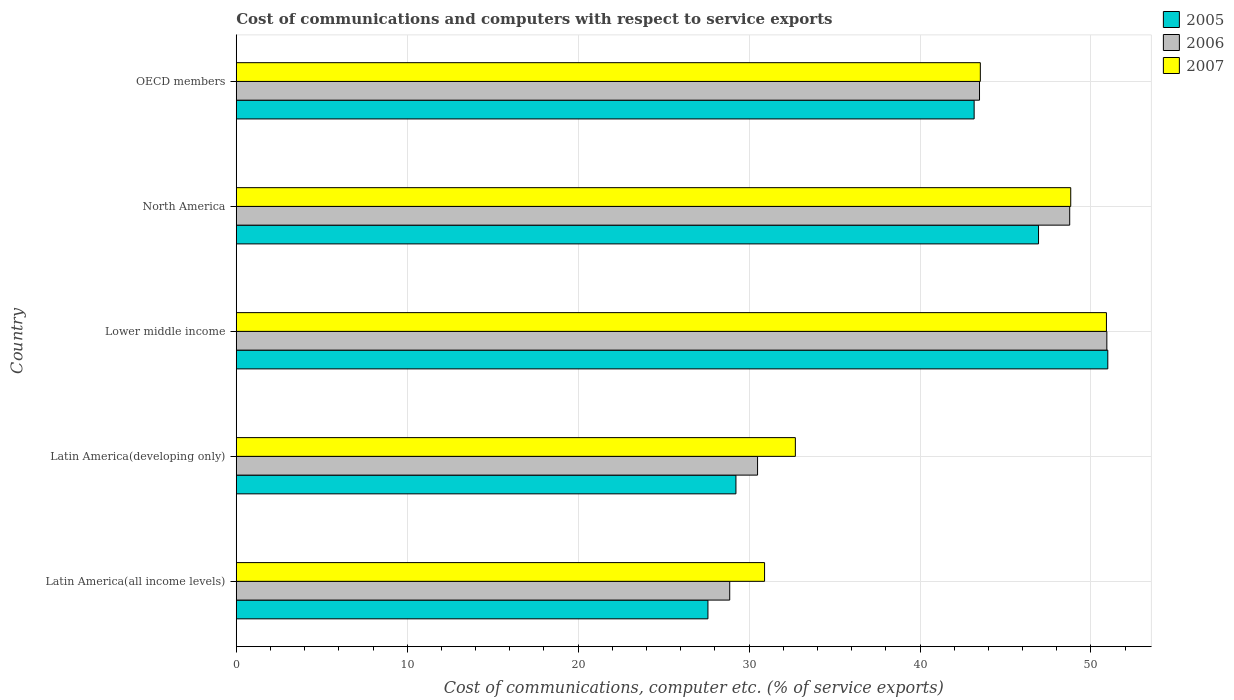How many different coloured bars are there?
Keep it short and to the point. 3. How many groups of bars are there?
Provide a short and direct response. 5. Are the number of bars per tick equal to the number of legend labels?
Your answer should be very brief. Yes. Are the number of bars on each tick of the Y-axis equal?
Offer a terse response. Yes. In how many cases, is the number of bars for a given country not equal to the number of legend labels?
Provide a short and direct response. 0. What is the cost of communications and computers in 2006 in North America?
Offer a terse response. 48.76. Across all countries, what is the maximum cost of communications and computers in 2005?
Provide a succinct answer. 50.99. Across all countries, what is the minimum cost of communications and computers in 2005?
Your response must be concise. 27.59. In which country was the cost of communications and computers in 2006 maximum?
Give a very brief answer. Lower middle income. In which country was the cost of communications and computers in 2006 minimum?
Your response must be concise. Latin America(all income levels). What is the total cost of communications and computers in 2007 in the graph?
Make the answer very short. 206.87. What is the difference between the cost of communications and computers in 2005 in Latin America(all income levels) and that in Lower middle income?
Keep it short and to the point. -23.39. What is the difference between the cost of communications and computers in 2005 in Latin America(all income levels) and the cost of communications and computers in 2007 in OECD members?
Provide a short and direct response. -15.94. What is the average cost of communications and computers in 2007 per country?
Make the answer very short. 41.37. What is the difference between the cost of communications and computers in 2005 and cost of communications and computers in 2006 in Lower middle income?
Offer a terse response. 0.05. In how many countries, is the cost of communications and computers in 2006 greater than 20 %?
Offer a terse response. 5. What is the ratio of the cost of communications and computers in 2006 in Lower middle income to that in North America?
Make the answer very short. 1.04. Is the cost of communications and computers in 2005 in Latin America(all income levels) less than that in Lower middle income?
Provide a short and direct response. Yes. Is the difference between the cost of communications and computers in 2005 in Lower middle income and OECD members greater than the difference between the cost of communications and computers in 2006 in Lower middle income and OECD members?
Make the answer very short. Yes. What is the difference between the highest and the second highest cost of communications and computers in 2005?
Make the answer very short. 4.05. What is the difference between the highest and the lowest cost of communications and computers in 2005?
Offer a terse response. 23.39. In how many countries, is the cost of communications and computers in 2007 greater than the average cost of communications and computers in 2007 taken over all countries?
Your answer should be very brief. 3. What does the 1st bar from the top in OECD members represents?
Provide a short and direct response. 2007. What does the 1st bar from the bottom in North America represents?
Provide a short and direct response. 2005. Are all the bars in the graph horizontal?
Your response must be concise. Yes. How many countries are there in the graph?
Keep it short and to the point. 5. Does the graph contain any zero values?
Your answer should be compact. No. Does the graph contain grids?
Provide a short and direct response. Yes. How are the legend labels stacked?
Give a very brief answer. Vertical. What is the title of the graph?
Offer a terse response. Cost of communications and computers with respect to service exports. What is the label or title of the X-axis?
Offer a terse response. Cost of communications, computer etc. (% of service exports). What is the Cost of communications, computer etc. (% of service exports) in 2005 in Latin America(all income levels)?
Give a very brief answer. 27.59. What is the Cost of communications, computer etc. (% of service exports) in 2006 in Latin America(all income levels)?
Your answer should be very brief. 28.87. What is the Cost of communications, computer etc. (% of service exports) in 2007 in Latin America(all income levels)?
Make the answer very short. 30.91. What is the Cost of communications, computer etc. (% of service exports) of 2005 in Latin America(developing only)?
Your response must be concise. 29.23. What is the Cost of communications, computer etc. (% of service exports) of 2006 in Latin America(developing only)?
Keep it short and to the point. 30.5. What is the Cost of communications, computer etc. (% of service exports) of 2007 in Latin America(developing only)?
Ensure brevity in your answer.  32.71. What is the Cost of communications, computer etc. (% of service exports) in 2005 in Lower middle income?
Keep it short and to the point. 50.99. What is the Cost of communications, computer etc. (% of service exports) of 2006 in Lower middle income?
Provide a short and direct response. 50.93. What is the Cost of communications, computer etc. (% of service exports) in 2007 in Lower middle income?
Your answer should be compact. 50.91. What is the Cost of communications, computer etc. (% of service exports) in 2005 in North America?
Make the answer very short. 46.93. What is the Cost of communications, computer etc. (% of service exports) in 2006 in North America?
Your response must be concise. 48.76. What is the Cost of communications, computer etc. (% of service exports) of 2007 in North America?
Your response must be concise. 48.82. What is the Cost of communications, computer etc. (% of service exports) of 2005 in OECD members?
Your answer should be very brief. 43.17. What is the Cost of communications, computer etc. (% of service exports) of 2006 in OECD members?
Provide a short and direct response. 43.48. What is the Cost of communications, computer etc. (% of service exports) of 2007 in OECD members?
Ensure brevity in your answer.  43.53. Across all countries, what is the maximum Cost of communications, computer etc. (% of service exports) in 2005?
Your answer should be very brief. 50.99. Across all countries, what is the maximum Cost of communications, computer etc. (% of service exports) of 2006?
Make the answer very short. 50.93. Across all countries, what is the maximum Cost of communications, computer etc. (% of service exports) of 2007?
Your response must be concise. 50.91. Across all countries, what is the minimum Cost of communications, computer etc. (% of service exports) of 2005?
Ensure brevity in your answer.  27.59. Across all countries, what is the minimum Cost of communications, computer etc. (% of service exports) of 2006?
Offer a terse response. 28.87. Across all countries, what is the minimum Cost of communications, computer etc. (% of service exports) in 2007?
Your response must be concise. 30.91. What is the total Cost of communications, computer etc. (% of service exports) of 2005 in the graph?
Provide a short and direct response. 197.91. What is the total Cost of communications, computer etc. (% of service exports) in 2006 in the graph?
Provide a short and direct response. 202.54. What is the total Cost of communications, computer etc. (% of service exports) of 2007 in the graph?
Keep it short and to the point. 206.87. What is the difference between the Cost of communications, computer etc. (% of service exports) in 2005 in Latin America(all income levels) and that in Latin America(developing only)?
Give a very brief answer. -1.64. What is the difference between the Cost of communications, computer etc. (% of service exports) in 2006 in Latin America(all income levels) and that in Latin America(developing only)?
Your answer should be compact. -1.63. What is the difference between the Cost of communications, computer etc. (% of service exports) in 2007 in Latin America(all income levels) and that in Latin America(developing only)?
Keep it short and to the point. -1.8. What is the difference between the Cost of communications, computer etc. (% of service exports) in 2005 in Latin America(all income levels) and that in Lower middle income?
Provide a succinct answer. -23.39. What is the difference between the Cost of communications, computer etc. (% of service exports) in 2006 in Latin America(all income levels) and that in Lower middle income?
Offer a very short reply. -22.06. What is the difference between the Cost of communications, computer etc. (% of service exports) of 2007 in Latin America(all income levels) and that in Lower middle income?
Ensure brevity in your answer.  -20. What is the difference between the Cost of communications, computer etc. (% of service exports) in 2005 in Latin America(all income levels) and that in North America?
Provide a short and direct response. -19.34. What is the difference between the Cost of communications, computer etc. (% of service exports) of 2006 in Latin America(all income levels) and that in North America?
Your answer should be very brief. -19.89. What is the difference between the Cost of communications, computer etc. (% of service exports) in 2007 in Latin America(all income levels) and that in North America?
Your answer should be very brief. -17.91. What is the difference between the Cost of communications, computer etc. (% of service exports) of 2005 in Latin America(all income levels) and that in OECD members?
Ensure brevity in your answer.  -15.57. What is the difference between the Cost of communications, computer etc. (% of service exports) of 2006 in Latin America(all income levels) and that in OECD members?
Give a very brief answer. -14.61. What is the difference between the Cost of communications, computer etc. (% of service exports) in 2007 in Latin America(all income levels) and that in OECD members?
Provide a succinct answer. -12.62. What is the difference between the Cost of communications, computer etc. (% of service exports) in 2005 in Latin America(developing only) and that in Lower middle income?
Ensure brevity in your answer.  -21.75. What is the difference between the Cost of communications, computer etc. (% of service exports) in 2006 in Latin America(developing only) and that in Lower middle income?
Keep it short and to the point. -20.43. What is the difference between the Cost of communications, computer etc. (% of service exports) in 2007 in Latin America(developing only) and that in Lower middle income?
Offer a terse response. -18.2. What is the difference between the Cost of communications, computer etc. (% of service exports) of 2005 in Latin America(developing only) and that in North America?
Offer a terse response. -17.7. What is the difference between the Cost of communications, computer etc. (% of service exports) in 2006 in Latin America(developing only) and that in North America?
Your answer should be compact. -18.26. What is the difference between the Cost of communications, computer etc. (% of service exports) of 2007 in Latin America(developing only) and that in North America?
Your response must be concise. -16.11. What is the difference between the Cost of communications, computer etc. (% of service exports) in 2005 in Latin America(developing only) and that in OECD members?
Provide a short and direct response. -13.93. What is the difference between the Cost of communications, computer etc. (% of service exports) in 2006 in Latin America(developing only) and that in OECD members?
Keep it short and to the point. -12.98. What is the difference between the Cost of communications, computer etc. (% of service exports) in 2007 in Latin America(developing only) and that in OECD members?
Give a very brief answer. -10.82. What is the difference between the Cost of communications, computer etc. (% of service exports) of 2005 in Lower middle income and that in North America?
Offer a very short reply. 4.05. What is the difference between the Cost of communications, computer etc. (% of service exports) in 2006 in Lower middle income and that in North America?
Give a very brief answer. 2.17. What is the difference between the Cost of communications, computer etc. (% of service exports) of 2007 in Lower middle income and that in North America?
Give a very brief answer. 2.09. What is the difference between the Cost of communications, computer etc. (% of service exports) of 2005 in Lower middle income and that in OECD members?
Ensure brevity in your answer.  7.82. What is the difference between the Cost of communications, computer etc. (% of service exports) in 2006 in Lower middle income and that in OECD members?
Keep it short and to the point. 7.45. What is the difference between the Cost of communications, computer etc. (% of service exports) of 2007 in Lower middle income and that in OECD members?
Offer a very short reply. 7.38. What is the difference between the Cost of communications, computer etc. (% of service exports) in 2005 in North America and that in OECD members?
Ensure brevity in your answer.  3.77. What is the difference between the Cost of communications, computer etc. (% of service exports) in 2006 in North America and that in OECD members?
Provide a short and direct response. 5.28. What is the difference between the Cost of communications, computer etc. (% of service exports) of 2007 in North America and that in OECD members?
Give a very brief answer. 5.29. What is the difference between the Cost of communications, computer etc. (% of service exports) in 2005 in Latin America(all income levels) and the Cost of communications, computer etc. (% of service exports) in 2006 in Latin America(developing only)?
Your response must be concise. -2.9. What is the difference between the Cost of communications, computer etc. (% of service exports) in 2005 in Latin America(all income levels) and the Cost of communications, computer etc. (% of service exports) in 2007 in Latin America(developing only)?
Offer a terse response. -5.11. What is the difference between the Cost of communications, computer etc. (% of service exports) of 2006 in Latin America(all income levels) and the Cost of communications, computer etc. (% of service exports) of 2007 in Latin America(developing only)?
Make the answer very short. -3.84. What is the difference between the Cost of communications, computer etc. (% of service exports) in 2005 in Latin America(all income levels) and the Cost of communications, computer etc. (% of service exports) in 2006 in Lower middle income?
Ensure brevity in your answer.  -23.34. What is the difference between the Cost of communications, computer etc. (% of service exports) in 2005 in Latin America(all income levels) and the Cost of communications, computer etc. (% of service exports) in 2007 in Lower middle income?
Offer a very short reply. -23.31. What is the difference between the Cost of communications, computer etc. (% of service exports) of 2006 in Latin America(all income levels) and the Cost of communications, computer etc. (% of service exports) of 2007 in Lower middle income?
Your answer should be compact. -22.04. What is the difference between the Cost of communications, computer etc. (% of service exports) in 2005 in Latin America(all income levels) and the Cost of communications, computer etc. (% of service exports) in 2006 in North America?
Your answer should be very brief. -21.16. What is the difference between the Cost of communications, computer etc. (% of service exports) in 2005 in Latin America(all income levels) and the Cost of communications, computer etc. (% of service exports) in 2007 in North America?
Ensure brevity in your answer.  -21.22. What is the difference between the Cost of communications, computer etc. (% of service exports) in 2006 in Latin America(all income levels) and the Cost of communications, computer etc. (% of service exports) in 2007 in North America?
Your answer should be very brief. -19.95. What is the difference between the Cost of communications, computer etc. (% of service exports) in 2005 in Latin America(all income levels) and the Cost of communications, computer etc. (% of service exports) in 2006 in OECD members?
Provide a succinct answer. -15.89. What is the difference between the Cost of communications, computer etc. (% of service exports) of 2005 in Latin America(all income levels) and the Cost of communications, computer etc. (% of service exports) of 2007 in OECD members?
Keep it short and to the point. -15.94. What is the difference between the Cost of communications, computer etc. (% of service exports) in 2006 in Latin America(all income levels) and the Cost of communications, computer etc. (% of service exports) in 2007 in OECD members?
Offer a terse response. -14.66. What is the difference between the Cost of communications, computer etc. (% of service exports) in 2005 in Latin America(developing only) and the Cost of communications, computer etc. (% of service exports) in 2006 in Lower middle income?
Give a very brief answer. -21.7. What is the difference between the Cost of communications, computer etc. (% of service exports) in 2005 in Latin America(developing only) and the Cost of communications, computer etc. (% of service exports) in 2007 in Lower middle income?
Offer a very short reply. -21.67. What is the difference between the Cost of communications, computer etc. (% of service exports) in 2006 in Latin America(developing only) and the Cost of communications, computer etc. (% of service exports) in 2007 in Lower middle income?
Your response must be concise. -20.41. What is the difference between the Cost of communications, computer etc. (% of service exports) in 2005 in Latin America(developing only) and the Cost of communications, computer etc. (% of service exports) in 2006 in North America?
Your answer should be compact. -19.53. What is the difference between the Cost of communications, computer etc. (% of service exports) of 2005 in Latin America(developing only) and the Cost of communications, computer etc. (% of service exports) of 2007 in North America?
Ensure brevity in your answer.  -19.59. What is the difference between the Cost of communications, computer etc. (% of service exports) of 2006 in Latin America(developing only) and the Cost of communications, computer etc. (% of service exports) of 2007 in North America?
Keep it short and to the point. -18.32. What is the difference between the Cost of communications, computer etc. (% of service exports) of 2005 in Latin America(developing only) and the Cost of communications, computer etc. (% of service exports) of 2006 in OECD members?
Keep it short and to the point. -14.25. What is the difference between the Cost of communications, computer etc. (% of service exports) in 2005 in Latin America(developing only) and the Cost of communications, computer etc. (% of service exports) in 2007 in OECD members?
Your response must be concise. -14.3. What is the difference between the Cost of communications, computer etc. (% of service exports) of 2006 in Latin America(developing only) and the Cost of communications, computer etc. (% of service exports) of 2007 in OECD members?
Offer a very short reply. -13.03. What is the difference between the Cost of communications, computer etc. (% of service exports) of 2005 in Lower middle income and the Cost of communications, computer etc. (% of service exports) of 2006 in North America?
Provide a succinct answer. 2.23. What is the difference between the Cost of communications, computer etc. (% of service exports) of 2005 in Lower middle income and the Cost of communications, computer etc. (% of service exports) of 2007 in North America?
Ensure brevity in your answer.  2.17. What is the difference between the Cost of communications, computer etc. (% of service exports) in 2006 in Lower middle income and the Cost of communications, computer etc. (% of service exports) in 2007 in North America?
Make the answer very short. 2.11. What is the difference between the Cost of communications, computer etc. (% of service exports) of 2005 in Lower middle income and the Cost of communications, computer etc. (% of service exports) of 2006 in OECD members?
Your answer should be very brief. 7.5. What is the difference between the Cost of communications, computer etc. (% of service exports) in 2005 in Lower middle income and the Cost of communications, computer etc. (% of service exports) in 2007 in OECD members?
Provide a short and direct response. 7.46. What is the difference between the Cost of communications, computer etc. (% of service exports) in 2006 in Lower middle income and the Cost of communications, computer etc. (% of service exports) in 2007 in OECD members?
Offer a very short reply. 7.4. What is the difference between the Cost of communications, computer etc. (% of service exports) in 2005 in North America and the Cost of communications, computer etc. (% of service exports) in 2006 in OECD members?
Provide a short and direct response. 3.45. What is the difference between the Cost of communications, computer etc. (% of service exports) in 2005 in North America and the Cost of communications, computer etc. (% of service exports) in 2007 in OECD members?
Provide a short and direct response. 3.41. What is the difference between the Cost of communications, computer etc. (% of service exports) of 2006 in North America and the Cost of communications, computer etc. (% of service exports) of 2007 in OECD members?
Make the answer very short. 5.23. What is the average Cost of communications, computer etc. (% of service exports) of 2005 per country?
Your answer should be compact. 39.58. What is the average Cost of communications, computer etc. (% of service exports) in 2006 per country?
Give a very brief answer. 40.51. What is the average Cost of communications, computer etc. (% of service exports) in 2007 per country?
Provide a short and direct response. 41.37. What is the difference between the Cost of communications, computer etc. (% of service exports) in 2005 and Cost of communications, computer etc. (% of service exports) in 2006 in Latin America(all income levels)?
Provide a succinct answer. -1.27. What is the difference between the Cost of communications, computer etc. (% of service exports) of 2005 and Cost of communications, computer etc. (% of service exports) of 2007 in Latin America(all income levels)?
Your response must be concise. -3.31. What is the difference between the Cost of communications, computer etc. (% of service exports) in 2006 and Cost of communications, computer etc. (% of service exports) in 2007 in Latin America(all income levels)?
Provide a short and direct response. -2.04. What is the difference between the Cost of communications, computer etc. (% of service exports) of 2005 and Cost of communications, computer etc. (% of service exports) of 2006 in Latin America(developing only)?
Offer a terse response. -1.26. What is the difference between the Cost of communications, computer etc. (% of service exports) of 2005 and Cost of communications, computer etc. (% of service exports) of 2007 in Latin America(developing only)?
Ensure brevity in your answer.  -3.48. What is the difference between the Cost of communications, computer etc. (% of service exports) in 2006 and Cost of communications, computer etc. (% of service exports) in 2007 in Latin America(developing only)?
Provide a short and direct response. -2.21. What is the difference between the Cost of communications, computer etc. (% of service exports) of 2005 and Cost of communications, computer etc. (% of service exports) of 2006 in Lower middle income?
Your response must be concise. 0.06. What is the difference between the Cost of communications, computer etc. (% of service exports) of 2005 and Cost of communications, computer etc. (% of service exports) of 2007 in Lower middle income?
Keep it short and to the point. 0.08. What is the difference between the Cost of communications, computer etc. (% of service exports) of 2006 and Cost of communications, computer etc. (% of service exports) of 2007 in Lower middle income?
Offer a terse response. 0.02. What is the difference between the Cost of communications, computer etc. (% of service exports) of 2005 and Cost of communications, computer etc. (% of service exports) of 2006 in North America?
Offer a terse response. -1.82. What is the difference between the Cost of communications, computer etc. (% of service exports) in 2005 and Cost of communications, computer etc. (% of service exports) in 2007 in North America?
Your answer should be compact. -1.88. What is the difference between the Cost of communications, computer etc. (% of service exports) of 2006 and Cost of communications, computer etc. (% of service exports) of 2007 in North America?
Your answer should be very brief. -0.06. What is the difference between the Cost of communications, computer etc. (% of service exports) in 2005 and Cost of communications, computer etc. (% of service exports) in 2006 in OECD members?
Provide a short and direct response. -0.32. What is the difference between the Cost of communications, computer etc. (% of service exports) in 2005 and Cost of communications, computer etc. (% of service exports) in 2007 in OECD members?
Provide a succinct answer. -0.36. What is the difference between the Cost of communications, computer etc. (% of service exports) in 2006 and Cost of communications, computer etc. (% of service exports) in 2007 in OECD members?
Give a very brief answer. -0.05. What is the ratio of the Cost of communications, computer etc. (% of service exports) in 2005 in Latin America(all income levels) to that in Latin America(developing only)?
Offer a very short reply. 0.94. What is the ratio of the Cost of communications, computer etc. (% of service exports) in 2006 in Latin America(all income levels) to that in Latin America(developing only)?
Offer a very short reply. 0.95. What is the ratio of the Cost of communications, computer etc. (% of service exports) in 2007 in Latin America(all income levels) to that in Latin America(developing only)?
Your response must be concise. 0.94. What is the ratio of the Cost of communications, computer etc. (% of service exports) in 2005 in Latin America(all income levels) to that in Lower middle income?
Keep it short and to the point. 0.54. What is the ratio of the Cost of communications, computer etc. (% of service exports) in 2006 in Latin America(all income levels) to that in Lower middle income?
Provide a short and direct response. 0.57. What is the ratio of the Cost of communications, computer etc. (% of service exports) of 2007 in Latin America(all income levels) to that in Lower middle income?
Provide a succinct answer. 0.61. What is the ratio of the Cost of communications, computer etc. (% of service exports) of 2005 in Latin America(all income levels) to that in North America?
Your response must be concise. 0.59. What is the ratio of the Cost of communications, computer etc. (% of service exports) in 2006 in Latin America(all income levels) to that in North America?
Provide a succinct answer. 0.59. What is the ratio of the Cost of communications, computer etc. (% of service exports) of 2007 in Latin America(all income levels) to that in North America?
Your answer should be very brief. 0.63. What is the ratio of the Cost of communications, computer etc. (% of service exports) in 2005 in Latin America(all income levels) to that in OECD members?
Provide a short and direct response. 0.64. What is the ratio of the Cost of communications, computer etc. (% of service exports) in 2006 in Latin America(all income levels) to that in OECD members?
Give a very brief answer. 0.66. What is the ratio of the Cost of communications, computer etc. (% of service exports) of 2007 in Latin America(all income levels) to that in OECD members?
Provide a succinct answer. 0.71. What is the ratio of the Cost of communications, computer etc. (% of service exports) of 2005 in Latin America(developing only) to that in Lower middle income?
Provide a succinct answer. 0.57. What is the ratio of the Cost of communications, computer etc. (% of service exports) of 2006 in Latin America(developing only) to that in Lower middle income?
Make the answer very short. 0.6. What is the ratio of the Cost of communications, computer etc. (% of service exports) in 2007 in Latin America(developing only) to that in Lower middle income?
Ensure brevity in your answer.  0.64. What is the ratio of the Cost of communications, computer etc. (% of service exports) of 2005 in Latin America(developing only) to that in North America?
Offer a very short reply. 0.62. What is the ratio of the Cost of communications, computer etc. (% of service exports) of 2006 in Latin America(developing only) to that in North America?
Offer a terse response. 0.63. What is the ratio of the Cost of communications, computer etc. (% of service exports) in 2007 in Latin America(developing only) to that in North America?
Give a very brief answer. 0.67. What is the ratio of the Cost of communications, computer etc. (% of service exports) in 2005 in Latin America(developing only) to that in OECD members?
Keep it short and to the point. 0.68. What is the ratio of the Cost of communications, computer etc. (% of service exports) of 2006 in Latin America(developing only) to that in OECD members?
Your answer should be very brief. 0.7. What is the ratio of the Cost of communications, computer etc. (% of service exports) of 2007 in Latin America(developing only) to that in OECD members?
Keep it short and to the point. 0.75. What is the ratio of the Cost of communications, computer etc. (% of service exports) of 2005 in Lower middle income to that in North America?
Offer a terse response. 1.09. What is the ratio of the Cost of communications, computer etc. (% of service exports) of 2006 in Lower middle income to that in North America?
Offer a very short reply. 1.04. What is the ratio of the Cost of communications, computer etc. (% of service exports) in 2007 in Lower middle income to that in North America?
Your response must be concise. 1.04. What is the ratio of the Cost of communications, computer etc. (% of service exports) of 2005 in Lower middle income to that in OECD members?
Provide a short and direct response. 1.18. What is the ratio of the Cost of communications, computer etc. (% of service exports) in 2006 in Lower middle income to that in OECD members?
Offer a very short reply. 1.17. What is the ratio of the Cost of communications, computer etc. (% of service exports) in 2007 in Lower middle income to that in OECD members?
Offer a very short reply. 1.17. What is the ratio of the Cost of communications, computer etc. (% of service exports) in 2005 in North America to that in OECD members?
Your answer should be very brief. 1.09. What is the ratio of the Cost of communications, computer etc. (% of service exports) of 2006 in North America to that in OECD members?
Give a very brief answer. 1.12. What is the ratio of the Cost of communications, computer etc. (% of service exports) in 2007 in North America to that in OECD members?
Make the answer very short. 1.12. What is the difference between the highest and the second highest Cost of communications, computer etc. (% of service exports) in 2005?
Your response must be concise. 4.05. What is the difference between the highest and the second highest Cost of communications, computer etc. (% of service exports) in 2006?
Your response must be concise. 2.17. What is the difference between the highest and the second highest Cost of communications, computer etc. (% of service exports) in 2007?
Provide a short and direct response. 2.09. What is the difference between the highest and the lowest Cost of communications, computer etc. (% of service exports) in 2005?
Your answer should be very brief. 23.39. What is the difference between the highest and the lowest Cost of communications, computer etc. (% of service exports) in 2006?
Your response must be concise. 22.06. What is the difference between the highest and the lowest Cost of communications, computer etc. (% of service exports) in 2007?
Your response must be concise. 20. 